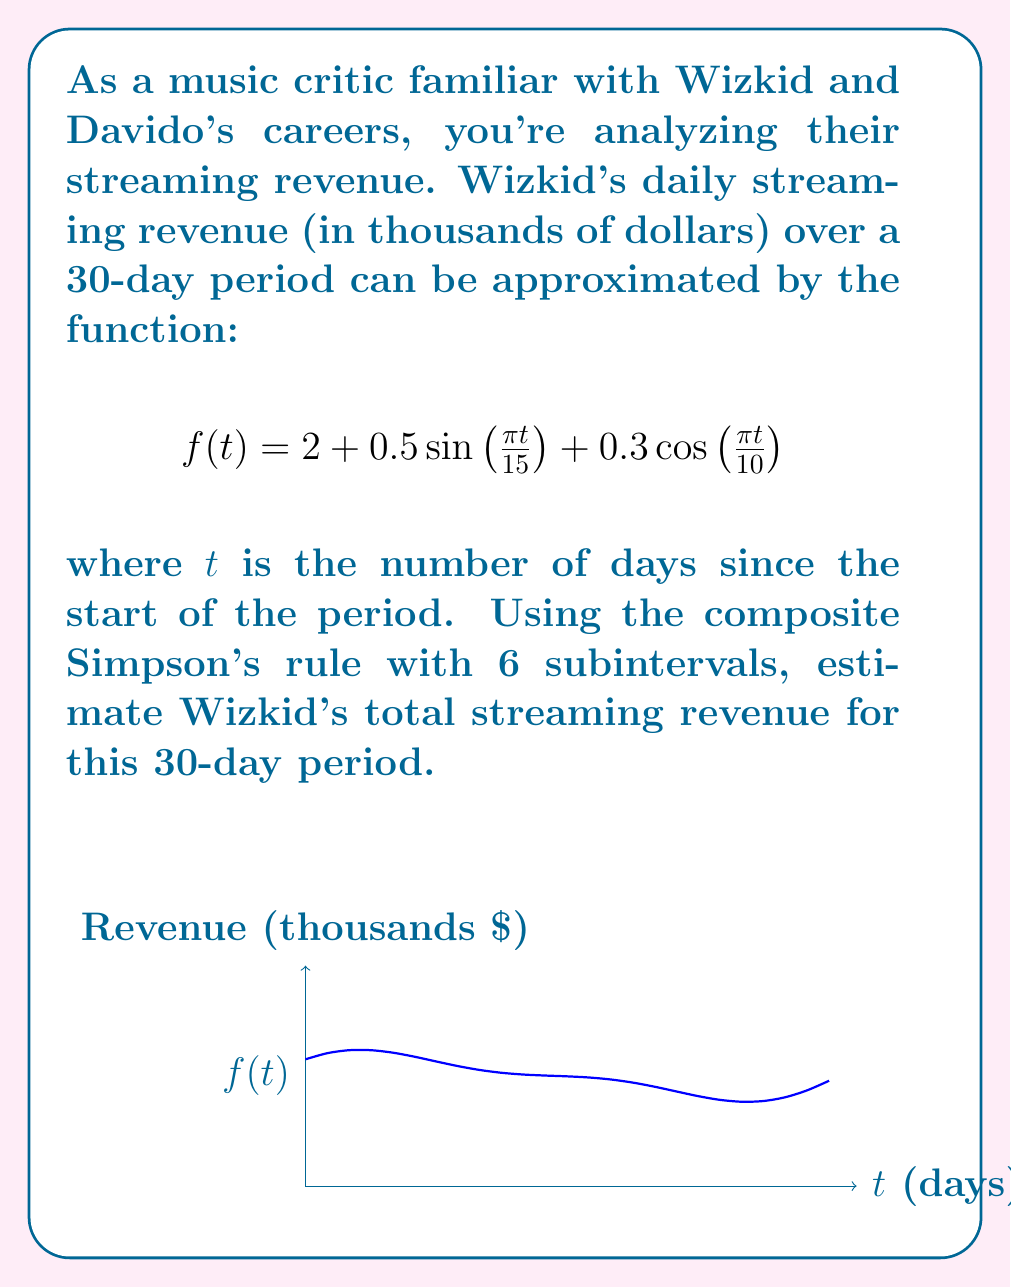Show me your answer to this math problem. To solve this problem using the composite Simpson's rule with 6 subintervals, we'll follow these steps:

1) The composite Simpson's rule formula is:

   $$\int_{a}^{b} f(x) dx \approx \frac{h}{3}[f(x_0) + 4f(x_1) + 2f(x_2) + 4f(x_3) + 2f(x_4) + 4f(x_5) + f(x_6)]$$

   where $h = \frac{b-a}{6}$ and $x_i = a + ih$ for $i = 0, 1, ..., 6$

2) In our case, $a = 0$, $b = 30$, so $h = \frac{30-0}{6} = 5$

3) We need to calculate $f(x_i)$ for $i = 0, 1, ..., 6$:

   $f(x_0) = f(0) = 2 + 0.5\sin(0) + 0.3\cos(0) = 2.3$
   $f(x_1) = f(5) = 2 + 0.5\sin(\frac{\pi}{3}) + 0.3\cos(\frac{\pi}{2}) = 2.433$
   $f(x_2) = f(10) = 2 + 0.5\sin(\frac{2\pi}{3}) - 0.3 = 2.133$
   $f(x_3) = f(15) = 2 + 0.5\sin(\pi) - 0.3\cos(\frac{3\pi}{2}) = 1.7$
   $f(x_4) = f(20) = 2 + 0.5\sin(\frac{4\pi}{3}) + 0.3 = 1.933$
   $f(x_5) = f(25) = 2 + 0.5\sin(\frac{5\pi}{3}) + 0.3\cos(\frac{5\pi}{2}) = 2.233$
   $f(x_6) = f(30) = 2 + 0.5\sin(2\pi) + 0.3\cos(3\pi) = 1.7$

4) Plugging these values into the composite Simpson's rule formula:

   $$\begin{align*}
   \int_{0}^{30} f(t) dt &\approx \frac{5}{3}[2.3 + 4(2.433) + 2(2.133) + 4(1.7) + 2(1.933) + 4(2.233) + 1.7] \\
   &= \frac{5}{3}[2.3 + 9.732 + 4.266 + 6.8 + 3.866 + 8.932 + 1.7] \\
   &= \frac{5}{3}(37.596) \\
   &= 62.66
   \end{align*}$$

5) This result is in thousands of dollars, so the total revenue is approximately $62,660.
Answer: $62,660 